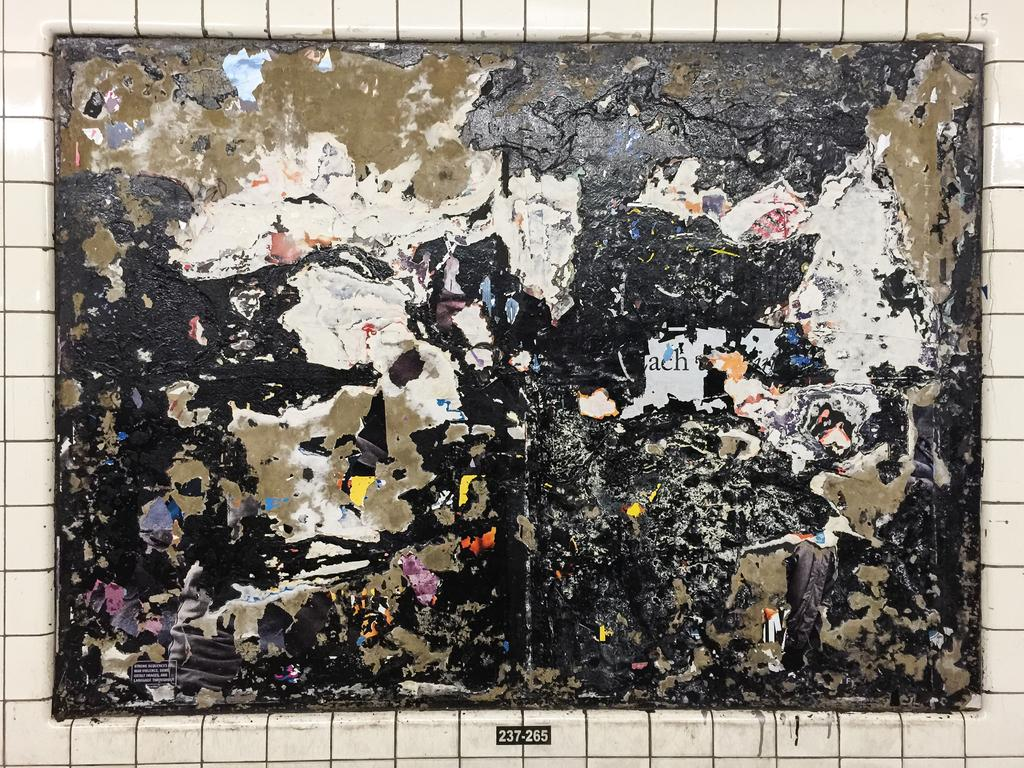<image>
Write a terse but informative summary of the picture. A wall with ripped up papers and the number 237-265 beneth it. 